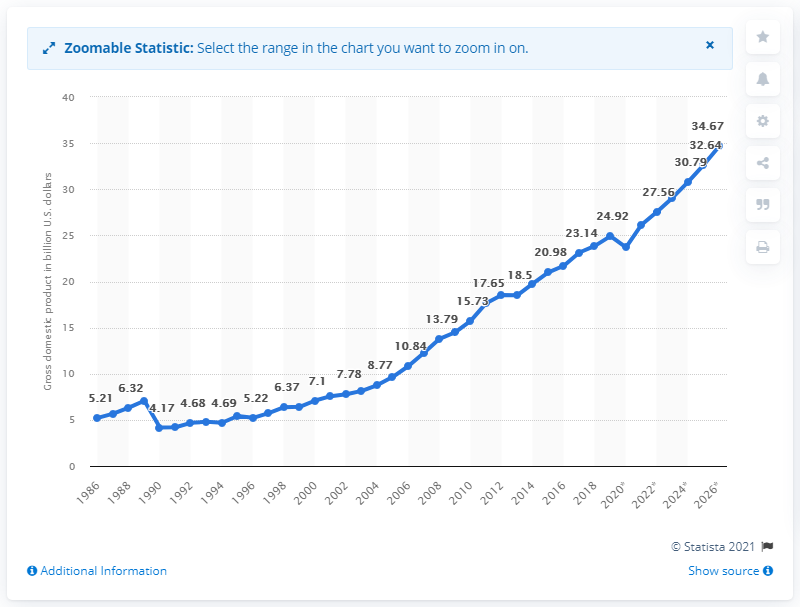Draw attention to some important aspects in this diagram. The gross domestic product of Honduras in 2019 was 24.92. 